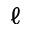<formula> <loc_0><loc_0><loc_500><loc_500>\ell</formula> 